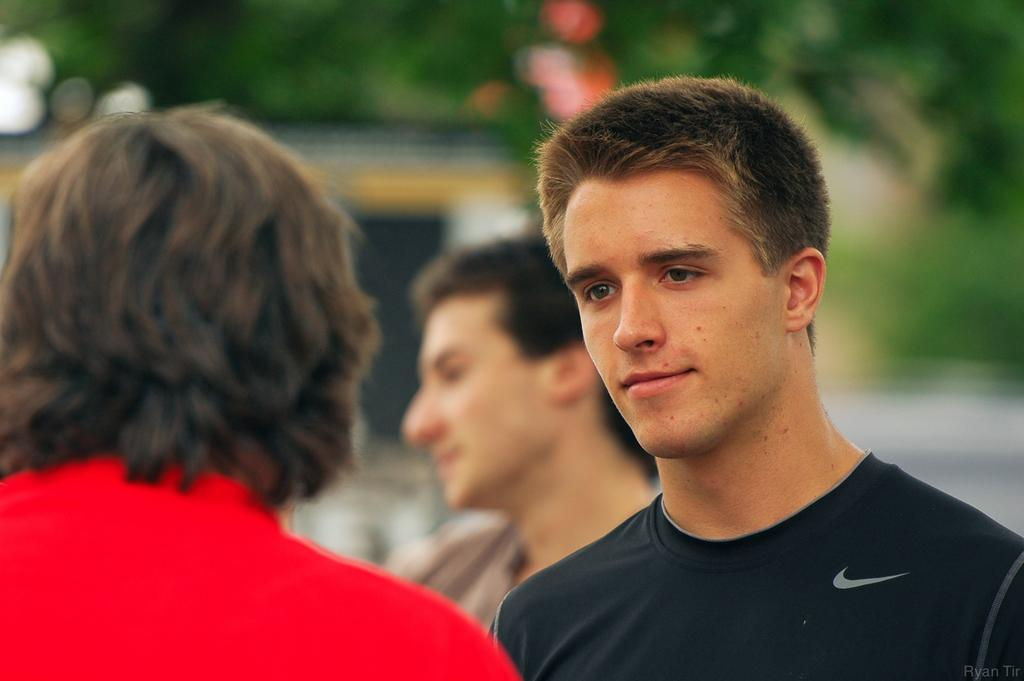How many people are present in the image? There are three people in the image. Can you describe the expression of one of the individuals? A man is smiling in the image. What type of natural environment is visible in the background? There are trees in the background of the image. How would you describe the clarity of the background? The background appears blurry. What type of toys can be seen in the hands of the father in the image? There is no father present in the image, and no toys are visible. 